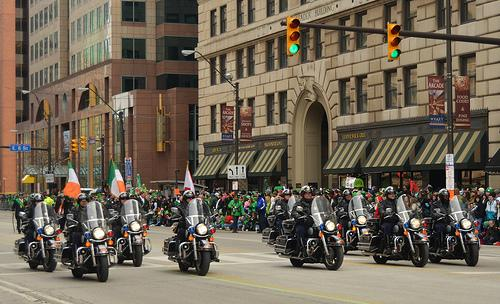Characterize the primary content and the surroundings in the image. Riders are on motorcycles in a vibrant cityscape, with buildings, different street signs, and a crowd of people nearby. Explain the most eye-catching element in the image and its context. People on motorcycles are the focal point, surrounded by a vivid city setting with pedestrians and assorted street signs. Illustrate the chief happening in the picture along with location specifics. Motorcyclists are seen riding down a bustling urban street lined with buildings, pedestrians, and a variety of street signs. Give a short description of the key subject and their action in the photo. Motorcyclists navigating through a busy city street filled with pedestrians, buildings, and traffic signals. Describe the most prominent action taking place in this image. Several individuals are riding motorcycles in a busy city street surrounded by buildings, people, and traffic lights. Portray the central occurrence in the picture and what is surrounding it. Motorcyclists traverse a bustling urban road with an abundance of signs and a throng of pedestrians in the background. What is the main event in the image and what is the setting like? The focal point is people riding motorcycles on a crowded city street with numerous signs and people walking around. Describe the principal object in the picture and the atmosphere around it. Motorcyclists take center stage amid a dynamic urban landscape teeming with street signs, buildings, and passersby. Summarize the main activity and its environment in the image. People are riding motorcycles in a lively city scene, featuring buildings, street signs, and various onlookers. Mention the primary focus of the image and describe its activity. A person is riding a motorcycle on a street filled with other motorcycles, with various street signs and people on the sidewalk. 